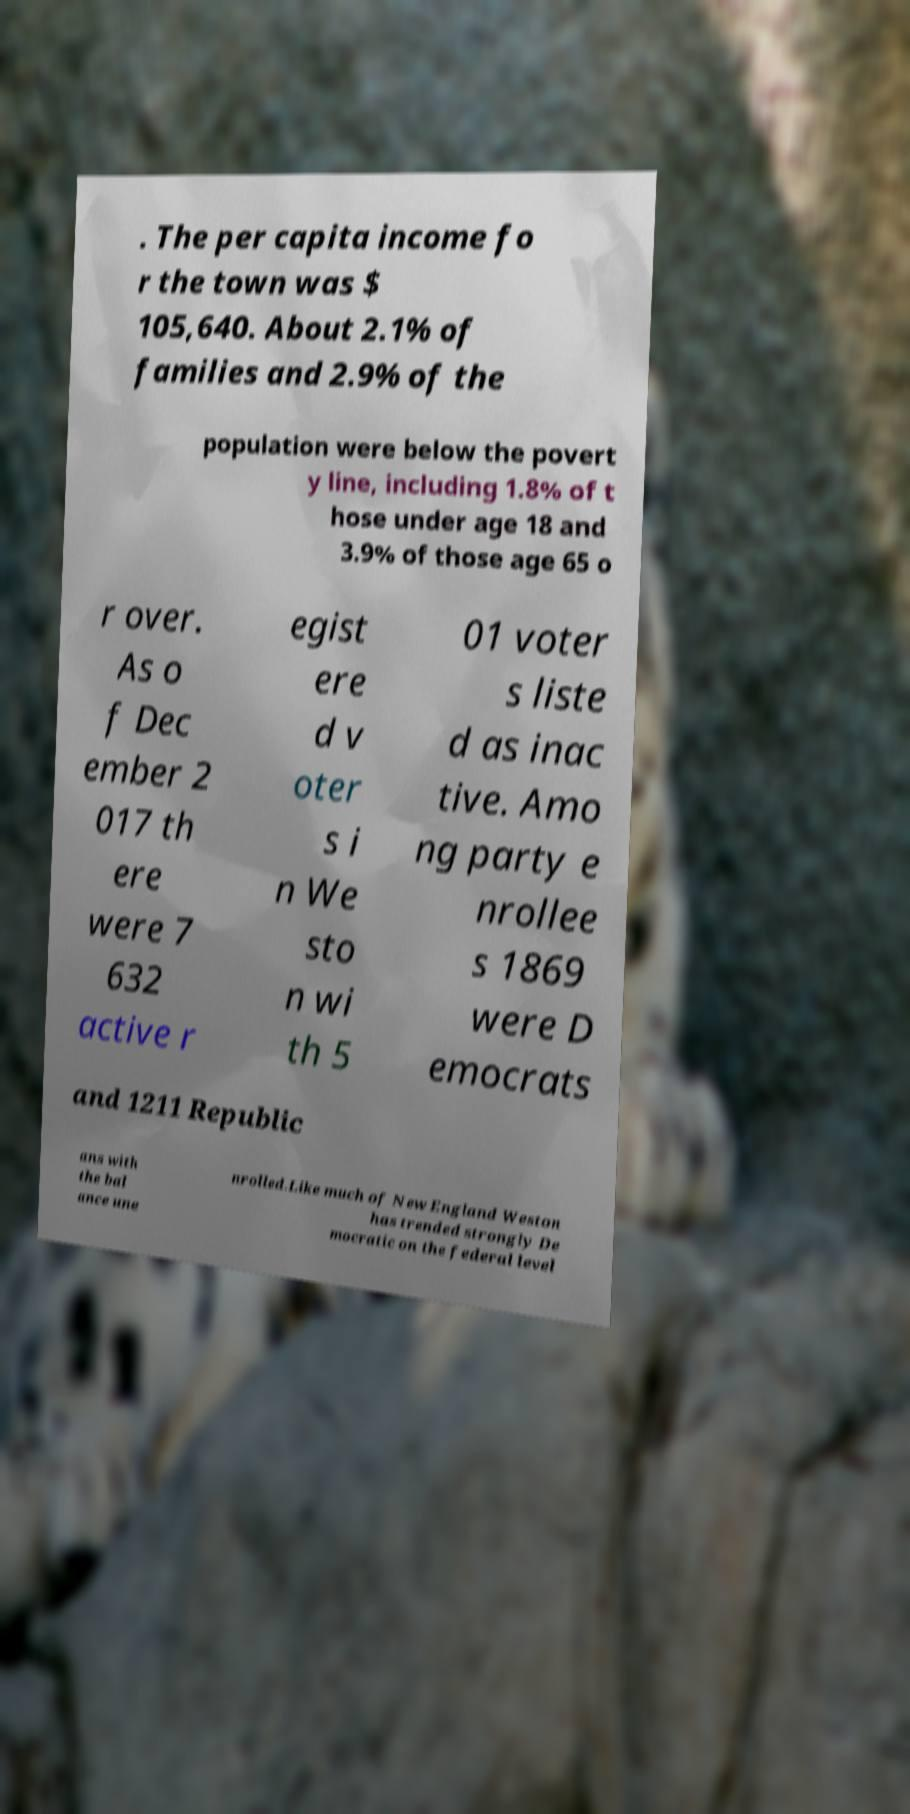What messages or text are displayed in this image? I need them in a readable, typed format. . The per capita income fo r the town was $ 105,640. About 2.1% of families and 2.9% of the population were below the povert y line, including 1.8% of t hose under age 18 and 3.9% of those age 65 o r over. As o f Dec ember 2 017 th ere were 7 632 active r egist ere d v oter s i n We sto n wi th 5 01 voter s liste d as inac tive. Amo ng party e nrollee s 1869 were D emocrats and 1211 Republic ans with the bal ance une nrolled.Like much of New England Weston has trended strongly De mocratic on the federal level 